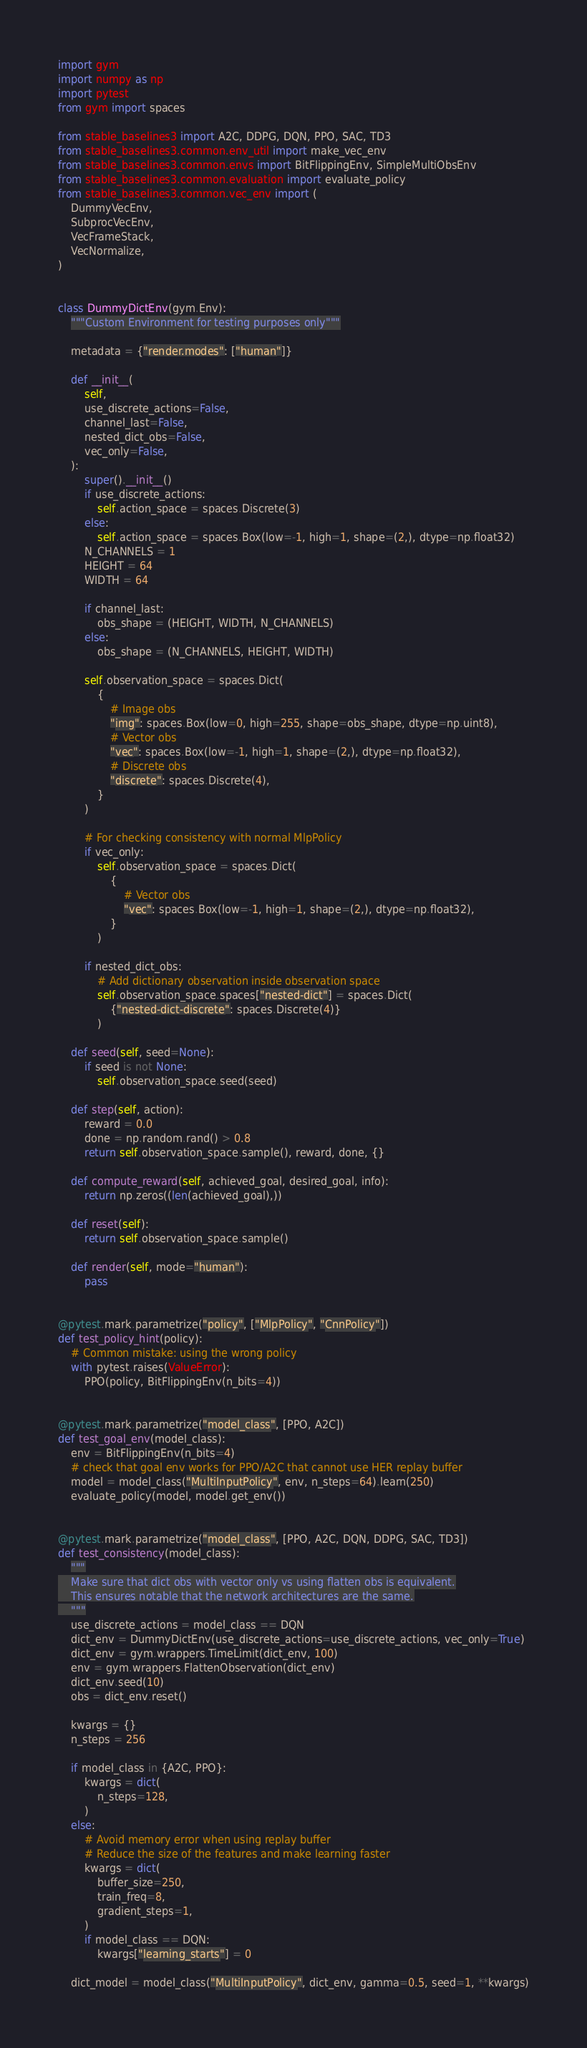Convert code to text. <code><loc_0><loc_0><loc_500><loc_500><_Python_>import gym
import numpy as np
import pytest
from gym import spaces

from stable_baselines3 import A2C, DDPG, DQN, PPO, SAC, TD3
from stable_baselines3.common.env_util import make_vec_env
from stable_baselines3.common.envs import BitFlippingEnv, SimpleMultiObsEnv
from stable_baselines3.common.evaluation import evaluate_policy
from stable_baselines3.common.vec_env import (
    DummyVecEnv,
    SubprocVecEnv,
    VecFrameStack,
    VecNormalize,
)


class DummyDictEnv(gym.Env):
    """Custom Environment for testing purposes only"""

    metadata = {"render.modes": ["human"]}

    def __init__(
        self,
        use_discrete_actions=False,
        channel_last=False,
        nested_dict_obs=False,
        vec_only=False,
    ):
        super().__init__()
        if use_discrete_actions:
            self.action_space = spaces.Discrete(3)
        else:
            self.action_space = spaces.Box(low=-1, high=1, shape=(2,), dtype=np.float32)
        N_CHANNELS = 1
        HEIGHT = 64
        WIDTH = 64

        if channel_last:
            obs_shape = (HEIGHT, WIDTH, N_CHANNELS)
        else:
            obs_shape = (N_CHANNELS, HEIGHT, WIDTH)

        self.observation_space = spaces.Dict(
            {
                # Image obs
                "img": spaces.Box(low=0, high=255, shape=obs_shape, dtype=np.uint8),
                # Vector obs
                "vec": spaces.Box(low=-1, high=1, shape=(2,), dtype=np.float32),
                # Discrete obs
                "discrete": spaces.Discrete(4),
            }
        )

        # For checking consistency with normal MlpPolicy
        if vec_only:
            self.observation_space = spaces.Dict(
                {
                    # Vector obs
                    "vec": spaces.Box(low=-1, high=1, shape=(2,), dtype=np.float32),
                }
            )

        if nested_dict_obs:
            # Add dictionary observation inside observation space
            self.observation_space.spaces["nested-dict"] = spaces.Dict(
                {"nested-dict-discrete": spaces.Discrete(4)}
            )

    def seed(self, seed=None):
        if seed is not None:
            self.observation_space.seed(seed)

    def step(self, action):
        reward = 0.0
        done = np.random.rand() > 0.8
        return self.observation_space.sample(), reward, done, {}

    def compute_reward(self, achieved_goal, desired_goal, info):
        return np.zeros((len(achieved_goal),))

    def reset(self):
        return self.observation_space.sample()

    def render(self, mode="human"):
        pass


@pytest.mark.parametrize("policy", ["MlpPolicy", "CnnPolicy"])
def test_policy_hint(policy):
    # Common mistake: using the wrong policy
    with pytest.raises(ValueError):
        PPO(policy, BitFlippingEnv(n_bits=4))


@pytest.mark.parametrize("model_class", [PPO, A2C])
def test_goal_env(model_class):
    env = BitFlippingEnv(n_bits=4)
    # check that goal env works for PPO/A2C that cannot use HER replay buffer
    model = model_class("MultiInputPolicy", env, n_steps=64).learn(250)
    evaluate_policy(model, model.get_env())


@pytest.mark.parametrize("model_class", [PPO, A2C, DQN, DDPG, SAC, TD3])
def test_consistency(model_class):
    """
    Make sure that dict obs with vector only vs using flatten obs is equivalent.
    This ensures notable that the network architectures are the same.
    """
    use_discrete_actions = model_class == DQN
    dict_env = DummyDictEnv(use_discrete_actions=use_discrete_actions, vec_only=True)
    dict_env = gym.wrappers.TimeLimit(dict_env, 100)
    env = gym.wrappers.FlattenObservation(dict_env)
    dict_env.seed(10)
    obs = dict_env.reset()

    kwargs = {}
    n_steps = 256

    if model_class in {A2C, PPO}:
        kwargs = dict(
            n_steps=128,
        )
    else:
        # Avoid memory error when using replay buffer
        # Reduce the size of the features and make learning faster
        kwargs = dict(
            buffer_size=250,
            train_freq=8,
            gradient_steps=1,
        )
        if model_class == DQN:
            kwargs["learning_starts"] = 0

    dict_model = model_class("MultiInputPolicy", dict_env, gamma=0.5, seed=1, **kwargs)</code> 